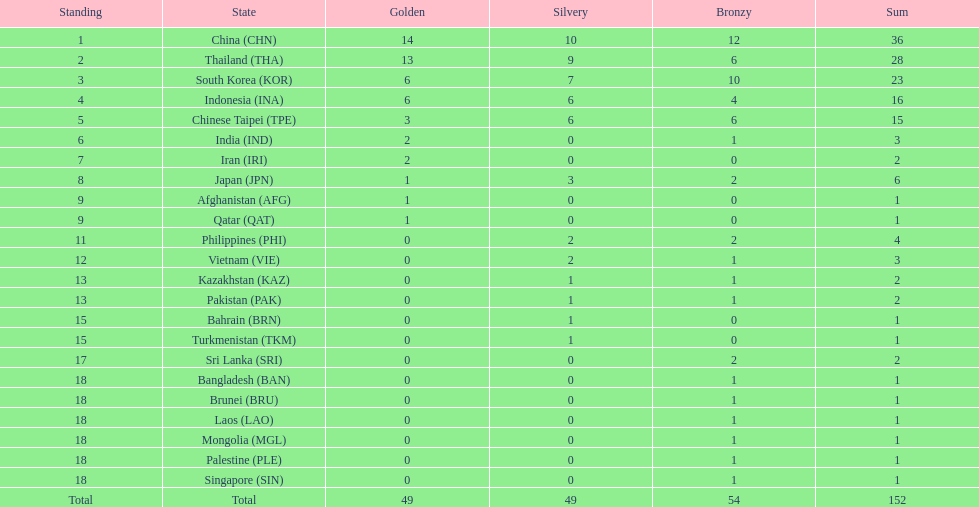How many nations received more than 5 gold medals? 4. 